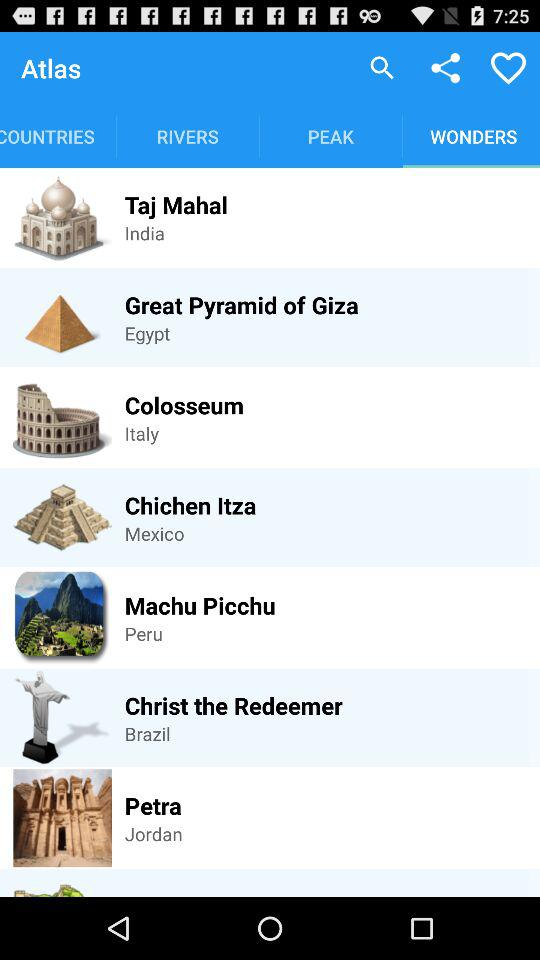Where is the Great Pyramid of Giza? the Great Pyramid of Giza in Egypt. 